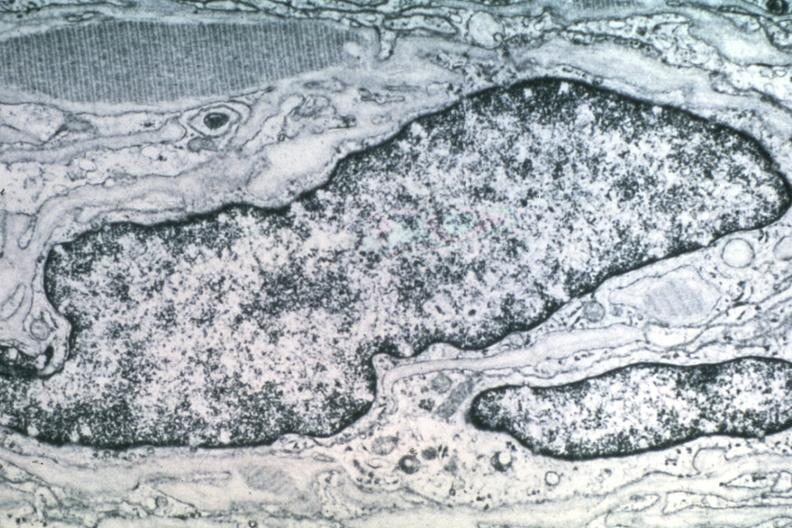what does this image show?
Answer the question using a single word or phrase. Dr garcia tumors 42 